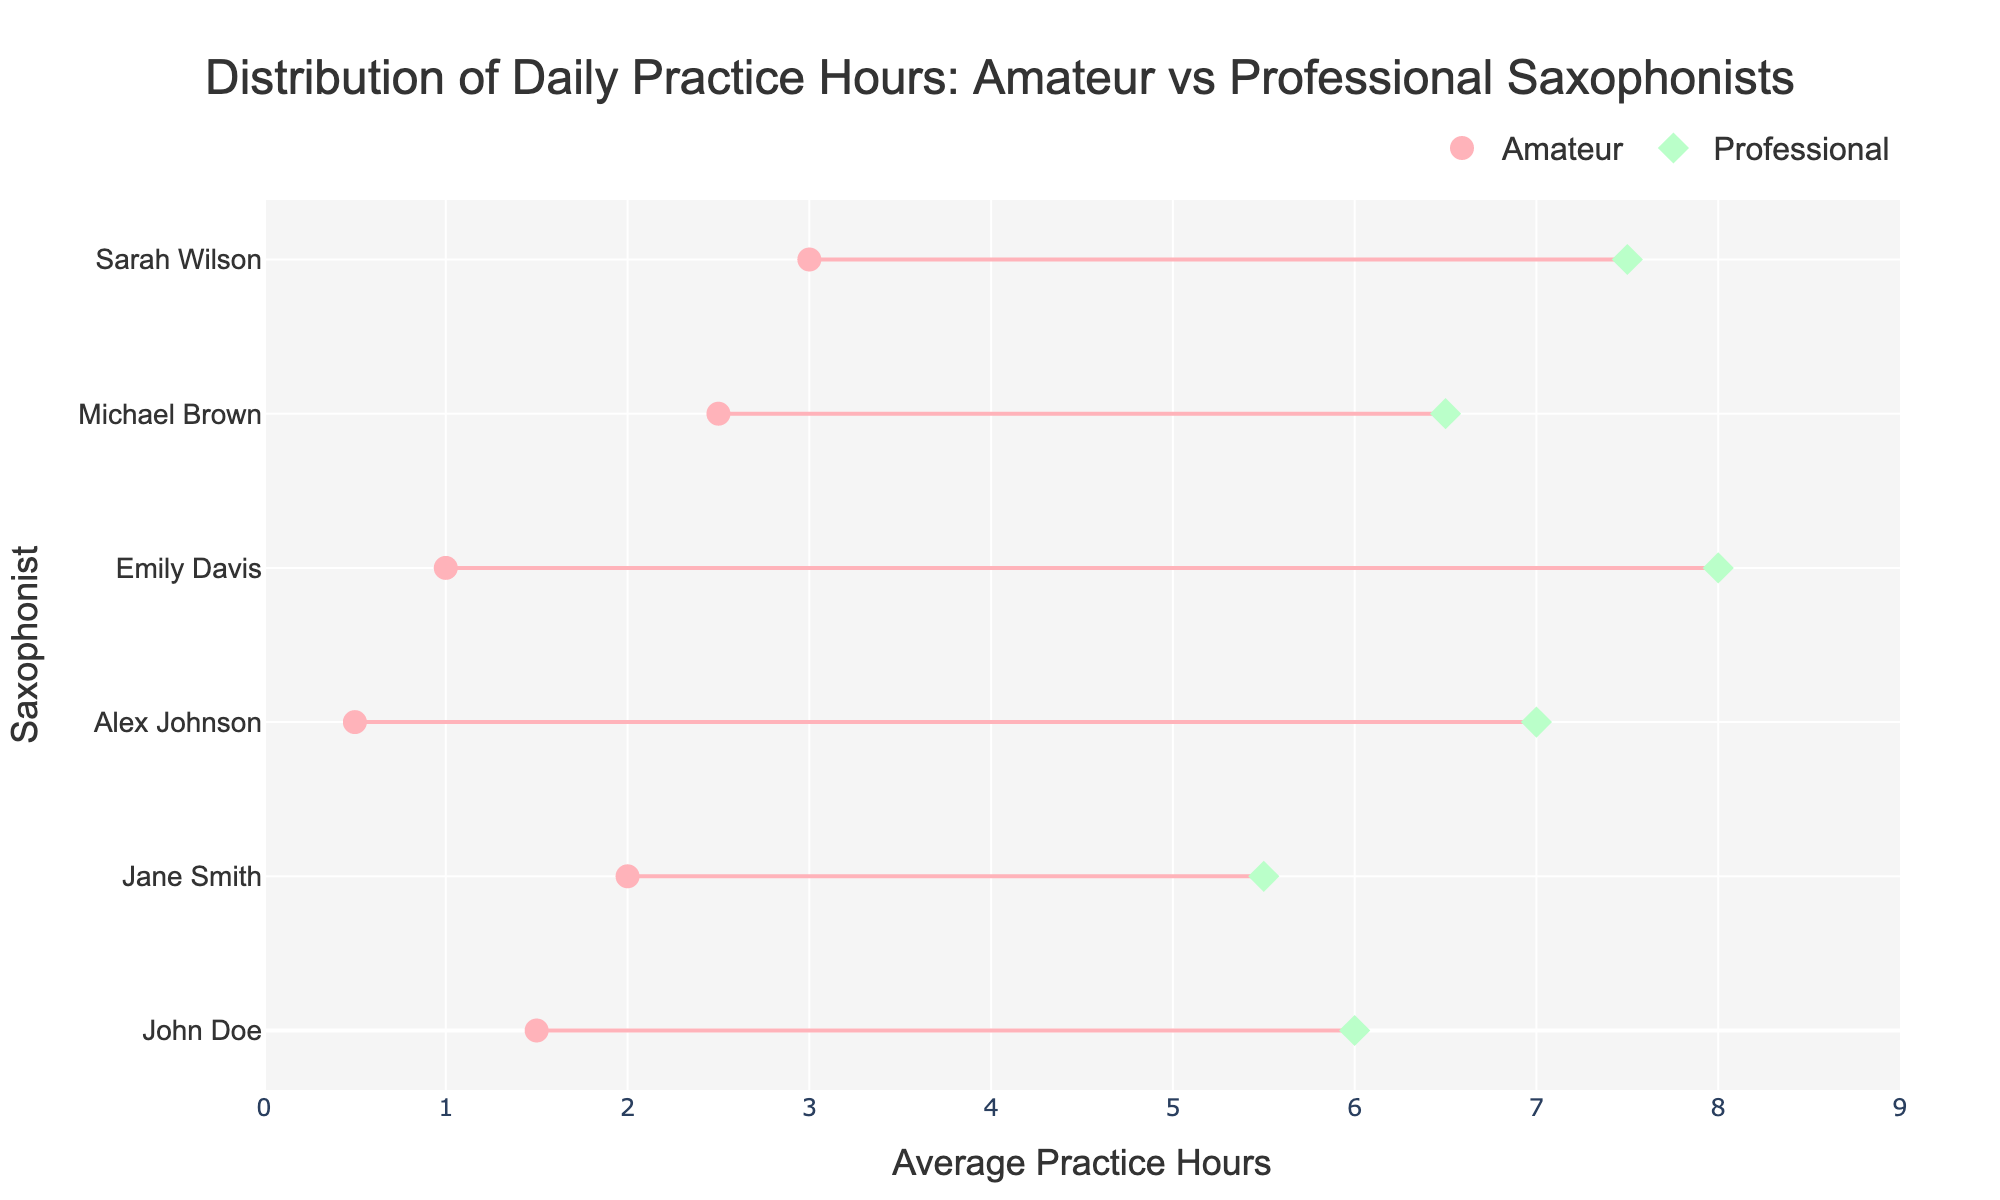What is the title of the plot? The title of the plot is clearly displayed at the top of the figure. It states "Distribution of Daily Practice Hours: Amateur vs Professional Saxophonists".
Answer: Distribution of Daily Practice Hours: Amateur vs Professional Saxophonists How many saxophonists are shown practicing daily? We can count the different markers in the plot. There are 6 amateur saxophonists and 6 professional saxophonists, so there are a total of 12 saxophonists practicing daily.
Answer: 12 What is the color used for the amateur saxophonists' markers? The color used for amateur saxophonists' markers is visible in the figure as circles, which are colored in a light pink shade.
Answer: light pink Which saxophonist has the highest average practice hours? By looking at the x-axis and spotting which professional marker (diamond) is highest, we see that it is Jessica Lewis with 8.0 hours.
Answer: Jessica Lewis What's the difference in average practice hours between the least practicing amateur and the most practicing professional? The least average practice hours for an amateur is Alex Johnson with 0.5 hours and the most for a professional is Jessica Lewis with 8.0 hours. The difference is 8.0 - 0.5 = 7.5 hours.
Answer: 7.5 hours What is the average daily practice hours of professional saxophonists? To find the average, sum the hours of all professional saxophonists and divide by the number of them. So (6.0 + 5.5 + 7.0 + 8.0 + 6.5 + 7.5) / 6 = 40.5 / 6 = 6.75 hours.
Answer: 6.75 hours Which group, amateurs or professionals, has a wider range of practice hours? We calculate the range for each group: 
Amateurs: Highest 3.0 (Sarah Wilson) - Lowest 0.5 (Alex Johnson) = 2.5 hours
Professionals: Highest 8.0 (Jessica Lewis) - Lowest 5.5 (Amanda White) = 2.5 hours
The range for both groups is the same.
Answer: Both groups have the same range Do amateur saxophonists practice more evenly distributed throughout the day compared to professional saxophonists? By visually inspecting the spread of markers along the x-axis, amateur saxophonists have a lower range of practice hours (0.5 to 3.0 hours). While professional practice hours range from 5.5 to 8.0, indicating a more clustered distribution at higher hours.
Answer: No Which saxophonist practices the least daily? Observing the leftmost point of the amateur markers, Alex Johnson has the lowest average practice hours of 0.5 hours.
Answer: Alex Johnson 